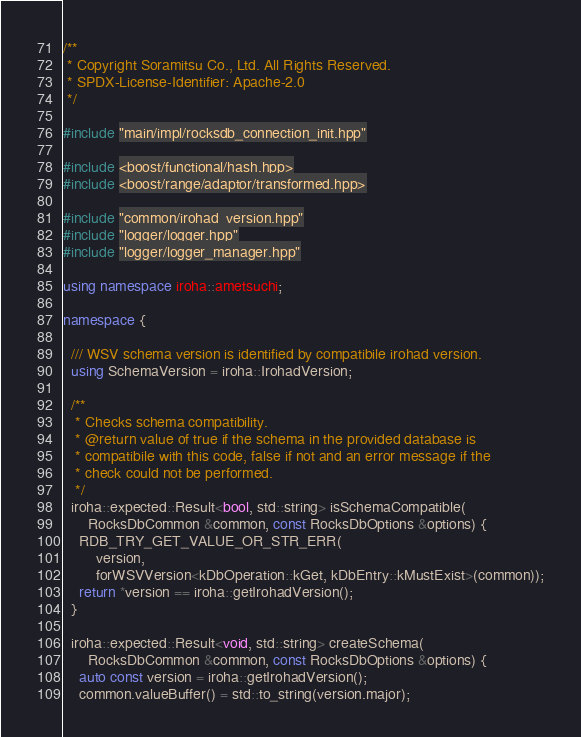<code> <loc_0><loc_0><loc_500><loc_500><_C++_>/**
 * Copyright Soramitsu Co., Ltd. All Rights Reserved.
 * SPDX-License-Identifier: Apache-2.0
 */

#include "main/impl/rocksdb_connection_init.hpp"

#include <boost/functional/hash.hpp>
#include <boost/range/adaptor/transformed.hpp>

#include "common/irohad_version.hpp"
#include "logger/logger.hpp"
#include "logger/logger_manager.hpp"

using namespace iroha::ametsuchi;

namespace {

  /// WSV schema version is identified by compatibile irohad version.
  using SchemaVersion = iroha::IrohadVersion;

  /**
   * Checks schema compatibility.
   * @return value of true if the schema in the provided database is
   * compatibile with this code, false if not and an error message if the
   * check could not be performed.
   */
  iroha::expected::Result<bool, std::string> isSchemaCompatible(
      RocksDbCommon &common, const RocksDbOptions &options) {
    RDB_TRY_GET_VALUE_OR_STR_ERR(
        version,
        forWSVVersion<kDbOperation::kGet, kDbEntry::kMustExist>(common));
    return *version == iroha::getIrohadVersion();
  }

  iroha::expected::Result<void, std::string> createSchema(
      RocksDbCommon &common, const RocksDbOptions &options) {
    auto const version = iroha::getIrohadVersion();
    common.valueBuffer() = std::to_string(version.major);</code> 